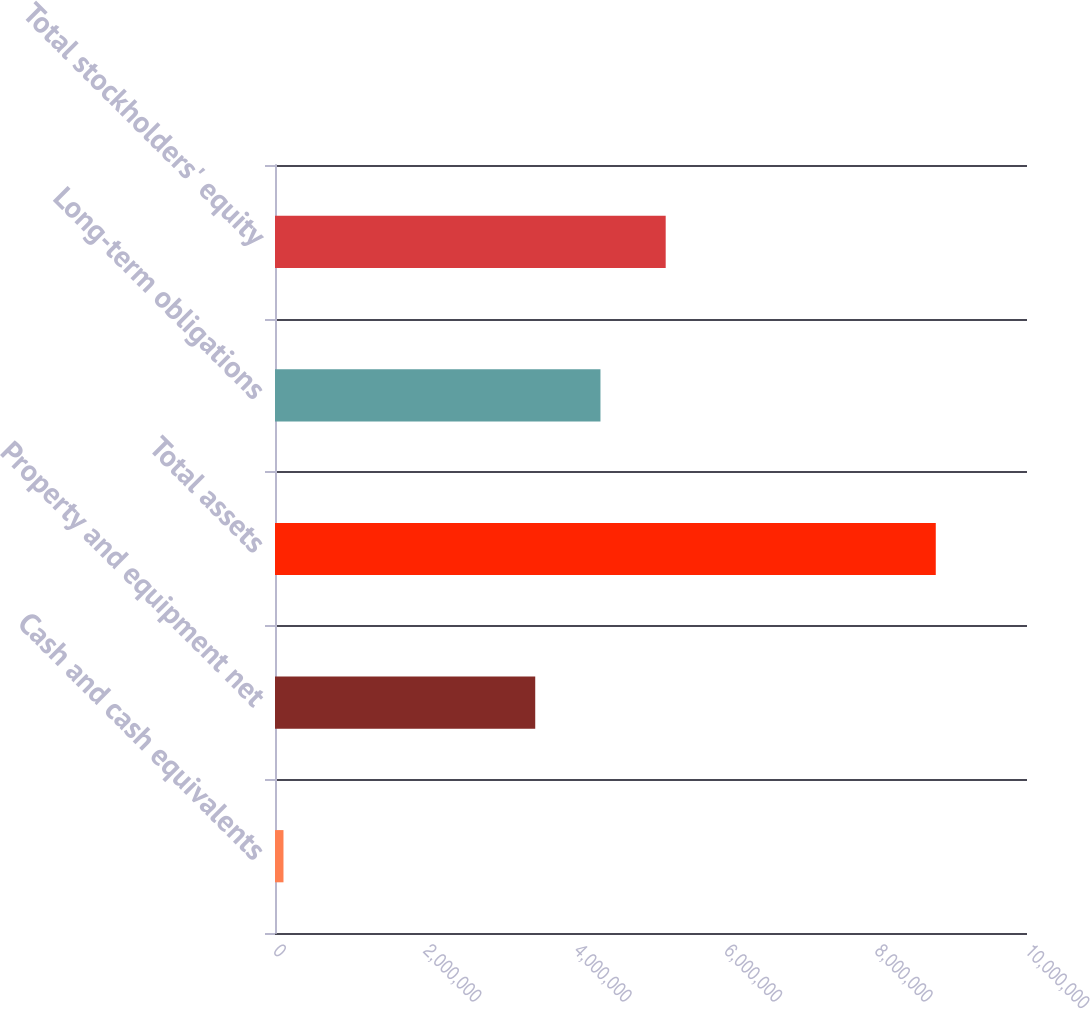Convert chart. <chart><loc_0><loc_0><loc_500><loc_500><bar_chart><fcel>Cash and cash equivalents<fcel>Property and equipment net<fcel>Total assets<fcel>Long-term obligations<fcel>Total stockholders' equity<nl><fcel>112701<fcel>3.46053e+06<fcel>8.78685e+06<fcel>4.32794e+06<fcel>5.19536e+06<nl></chart> 